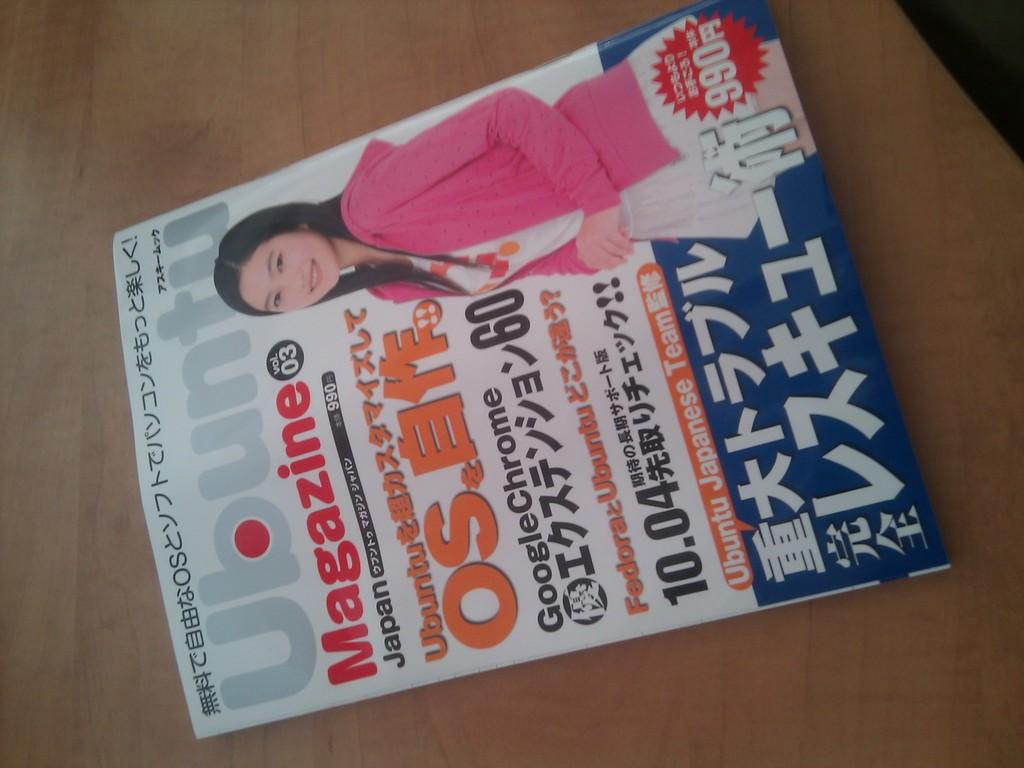What is the medium of the image? The image is on a paper. What is depicted in the image on the paper? There is an image of a woman on the paper. What is the woman wearing in the image? The woman is wearing a pink dress in the image. What type of bomb can be seen in the image? There is no bomb present in the image; it features an image of a woman wearing a pink dress. What is the woman doing on the moon in the image? There is no moon or indication of the woman being on the moon in the image. 